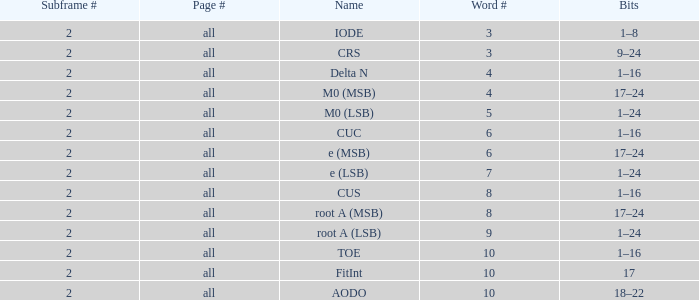How many subframes are there with bits ranging from 18 to 22? 2.0. 